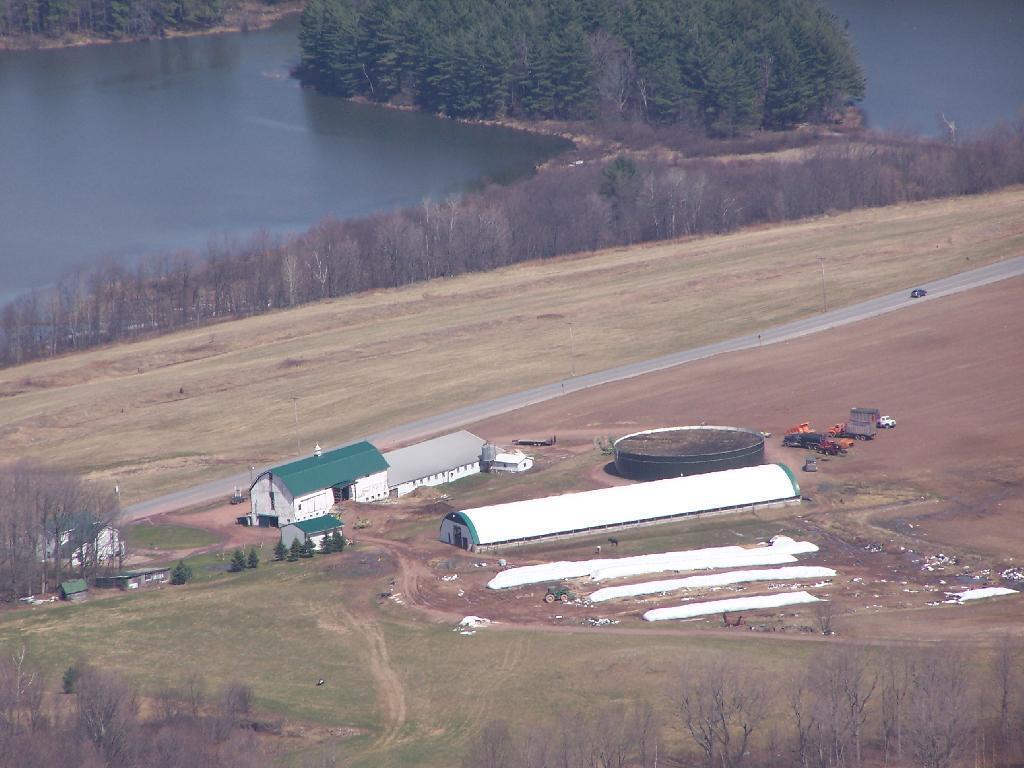Please provide a concise description of this image. As we can see in the image there are buildings, trees and vehicles. There is water and grass. 